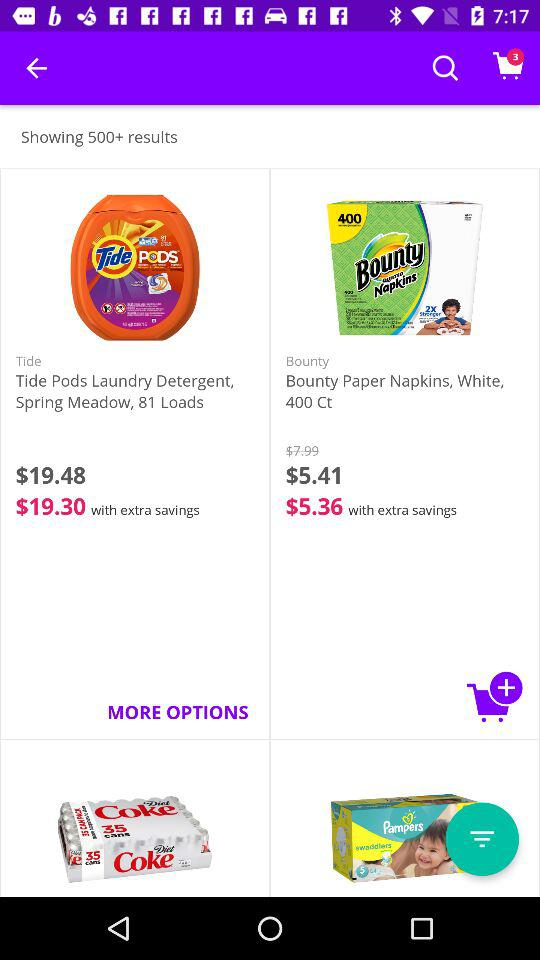How many items are in the cart? There are 3 items in the cart. 